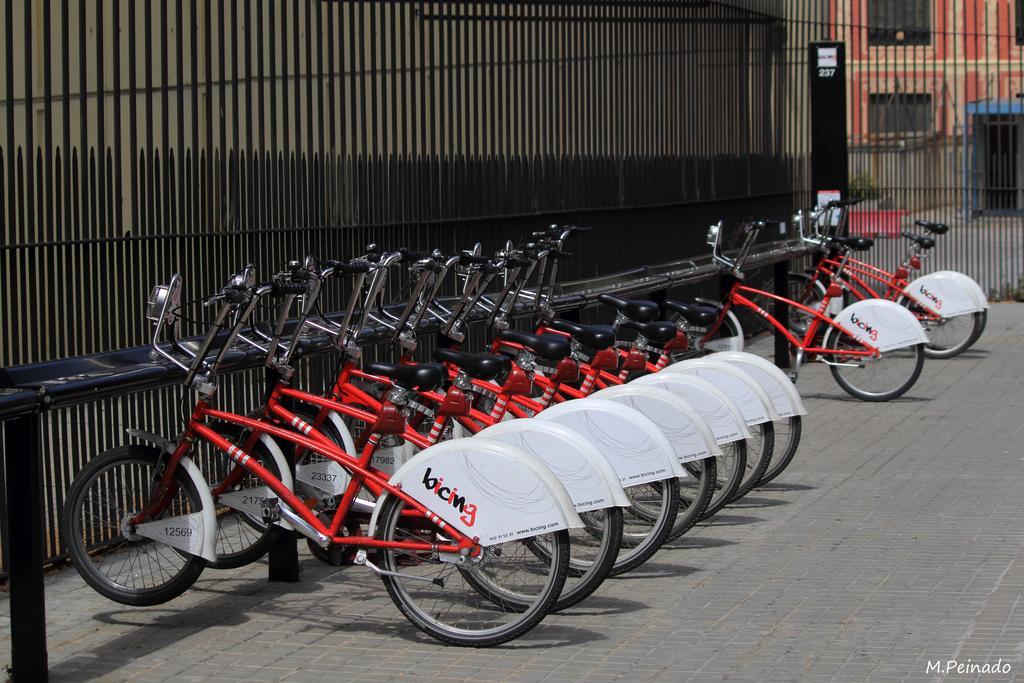Describe this image in one or two sentences. In this image we can see red color bicycles are parked, behind it black color grille and building is present. 